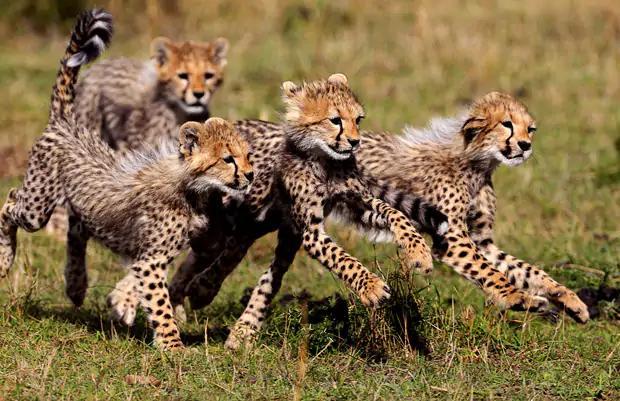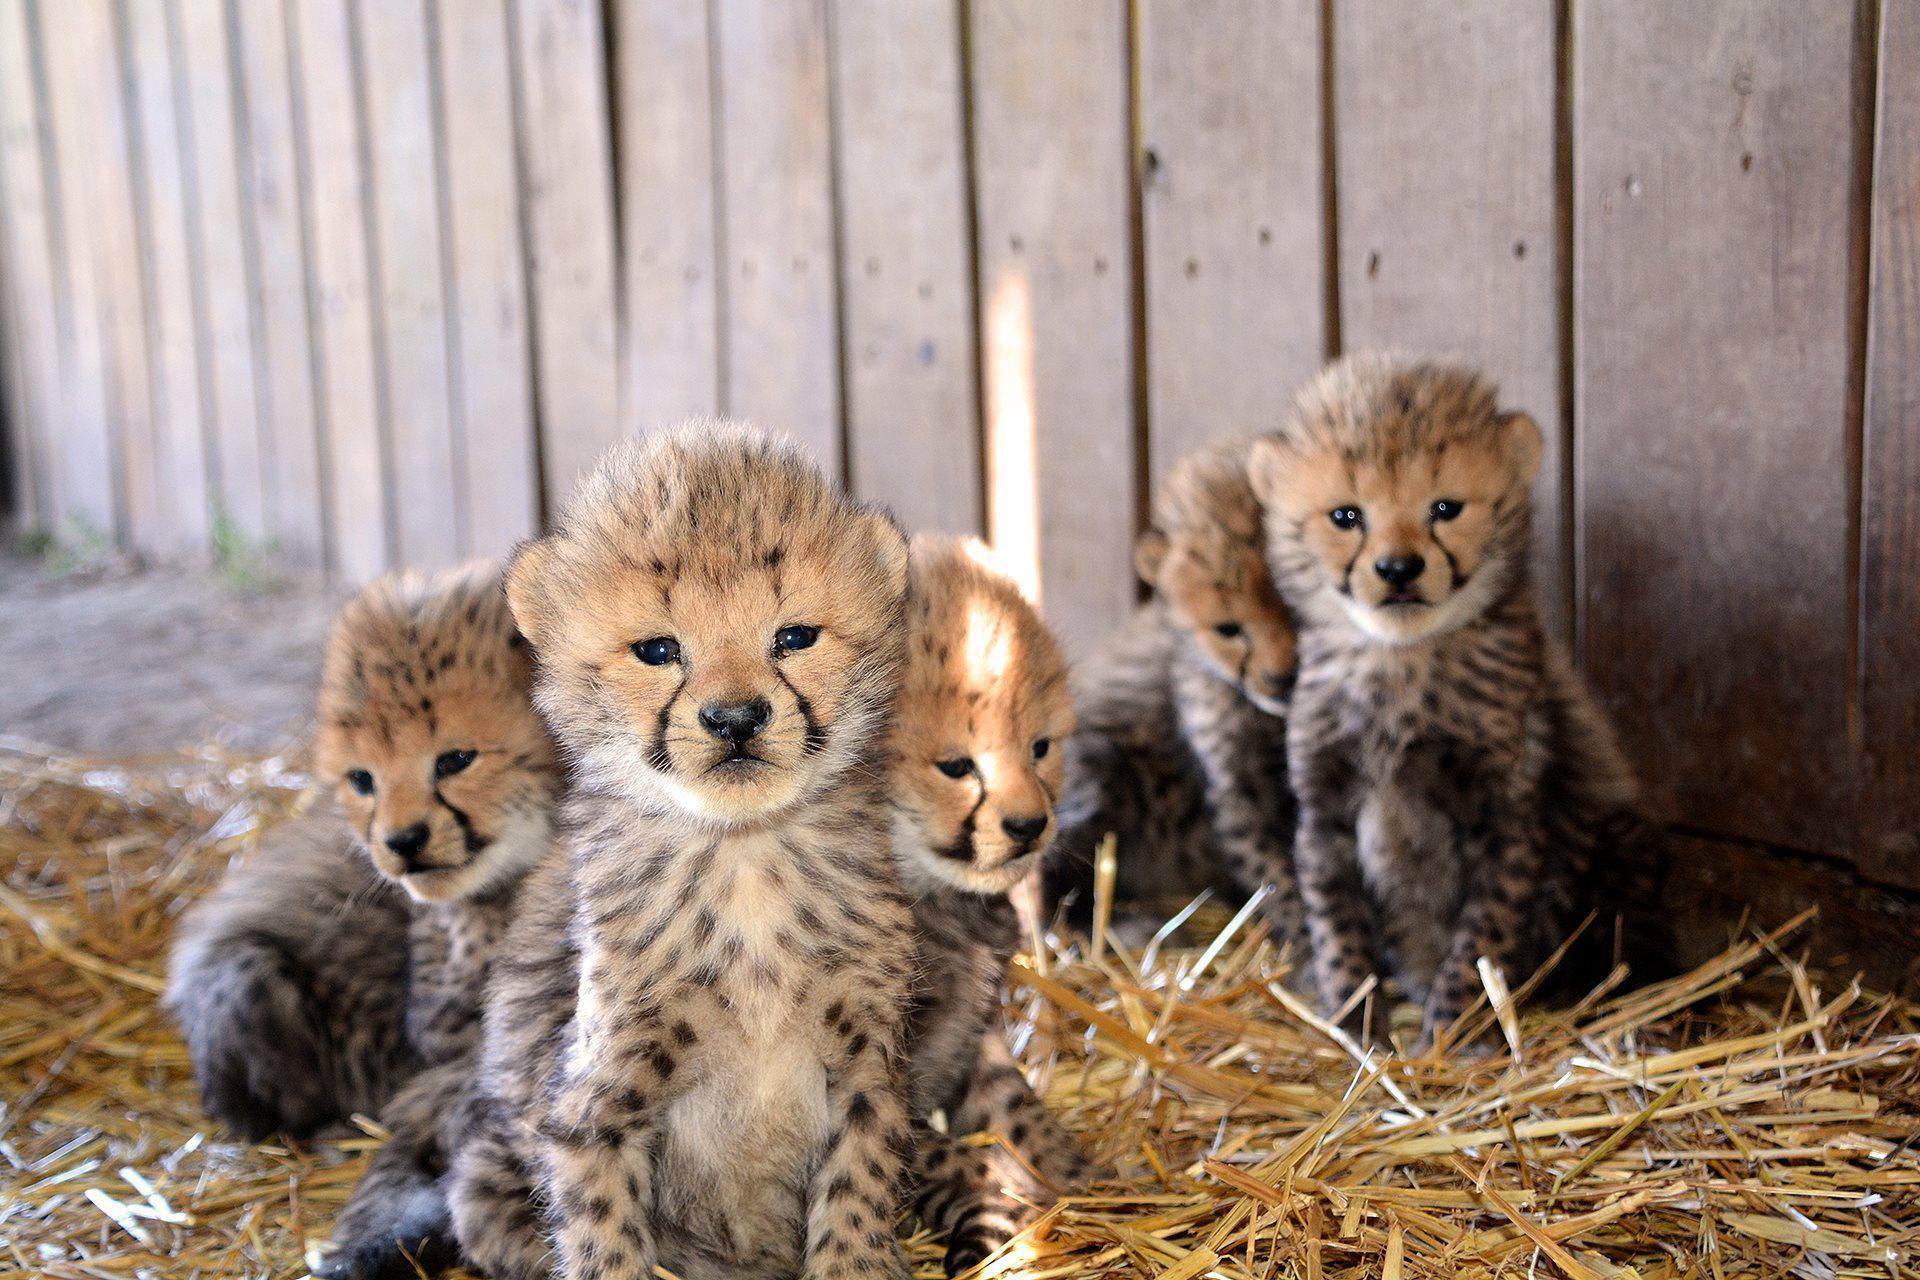The first image is the image on the left, the second image is the image on the right. Assess this claim about the two images: "An image contains exactly one cheetah.". Correct or not? Answer yes or no. No. The first image is the image on the left, the second image is the image on the right. For the images displayed, is the sentence "The combined images include at least one adult cheetah and at least six fuzzy-headed baby cheetahs." factually correct? Answer yes or no. No. 